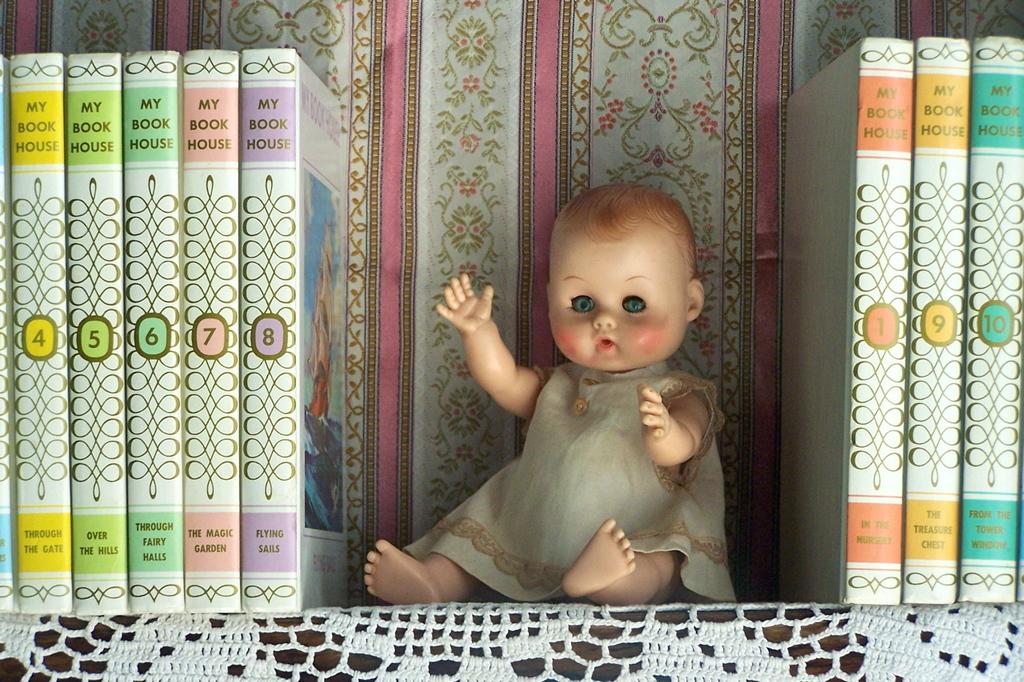Are these my book house books?
Provide a short and direct response. Yes. 